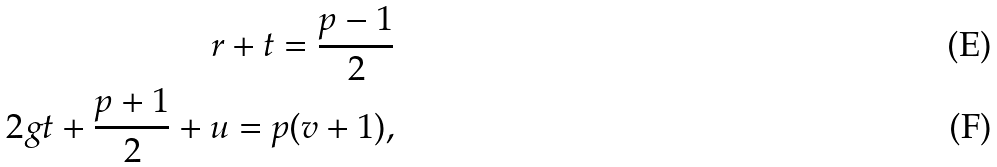<formula> <loc_0><loc_0><loc_500><loc_500>r + t = \frac { p - 1 } { 2 } \\ 2 g t + \frac { p + 1 } { 2 } + u = p ( v + 1 ) ,</formula> 